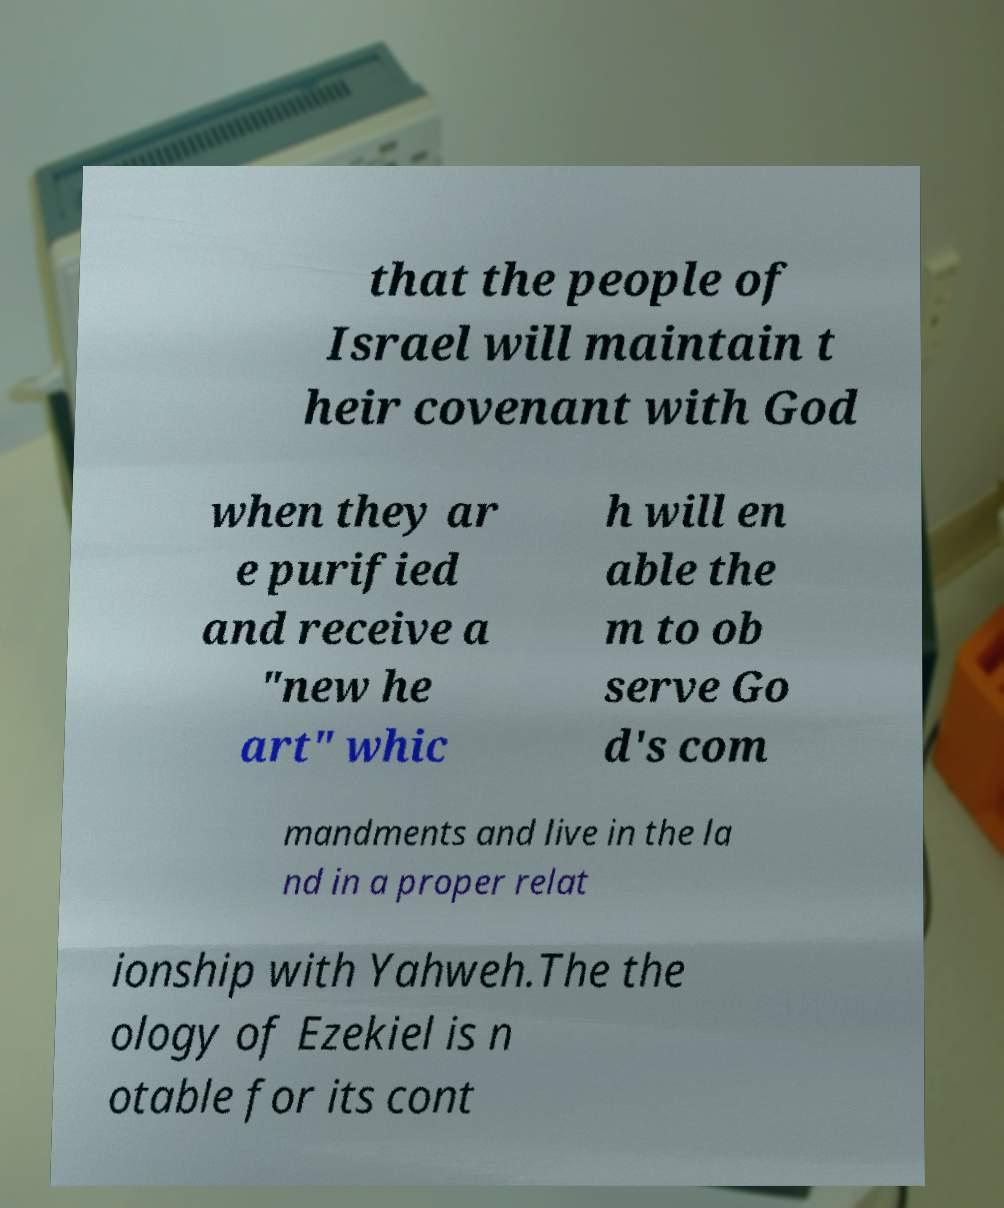There's text embedded in this image that I need extracted. Can you transcribe it verbatim? that the people of Israel will maintain t heir covenant with God when they ar e purified and receive a "new he art" whic h will en able the m to ob serve Go d's com mandments and live in the la nd in a proper relat ionship with Yahweh.The the ology of Ezekiel is n otable for its cont 